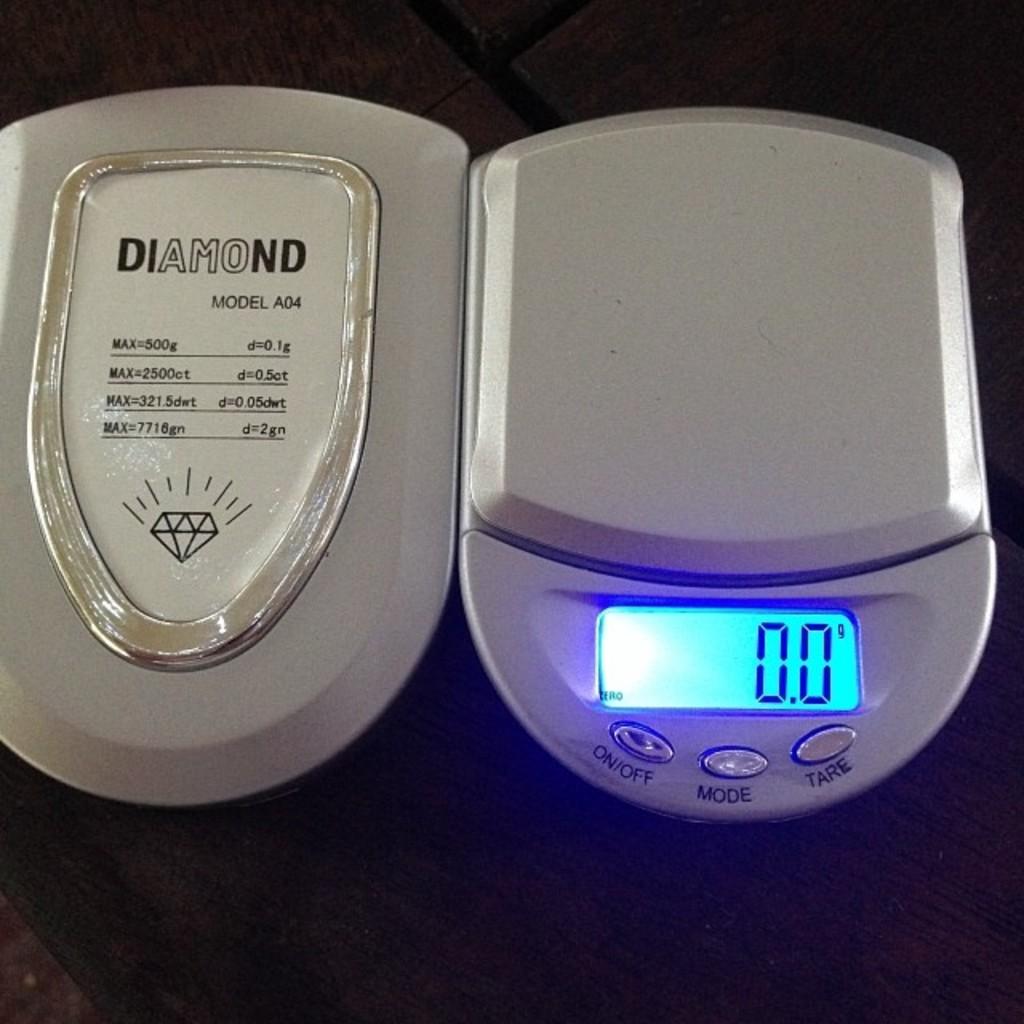What is the name of the scale?
Your response must be concise. Diamond. What is the model number of the scale?
Provide a short and direct response. A04. 